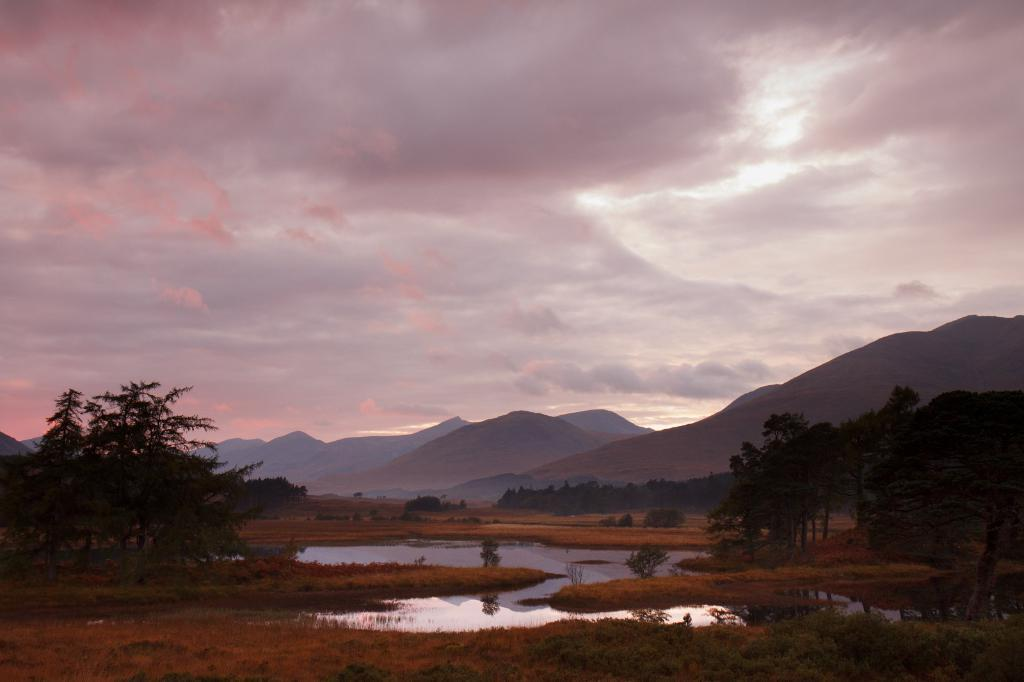What type of vegetation can be seen in the image? There is grass and plants visible in the image. What natural element is present in the image? There is water visible in the image. What type of landscape feature can be seen in the image? There are trees and hills visible in the image. What is visible in the background of the image? The sky is visible in the background of the image, and clouds are present in the sky. What type of legal advice is being given in the image? There is no lawyer or legal advice present in the image; it features natural elements and landscape features. What type of friction can be observed between the grass and the clouds in the image? There is no friction between the grass and the clouds in the image, as they are separate elements in the scene. 